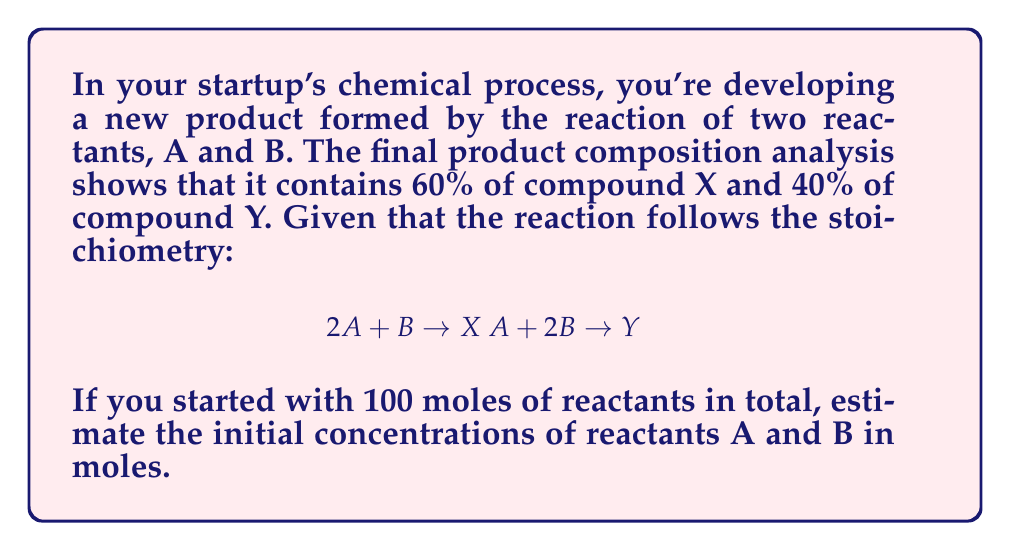Solve this math problem. Let's approach this step-by-step:

1) Let $a$ be the number of moles of A and $b$ be the number of moles of B. We know:

   $a + b = 100$ (total moles)

2) The product contains 60% X and 40% Y. Let's assume we have 100 moles of product for simplicity. Then:

   60 moles of X
   40 moles of Y

3) From the stoichiometry:
   For X: $2A + B \rightarrow X$
   For Y: $A + 2B \rightarrow Y$

4) To produce 60 moles of X:
   $120$ moles of A and $60$ moles of B were consumed

5) To produce 40 moles of Y:
   $40$ moles of A and $80$ moles of B were consumed

6) Total consumption:
   A: $120 + 40 = 160$ moles
   B: $60 + 80 = 140$ moles

7) The ratio of A:B consumption is 160:140, which simplifies to 8:7

8) We can set up an equation:
   $\frac{a}{8} = \frac{b}{7}$

9) Combining with the total moles equation:
   $a + b = 100$
   $7a = 8b$

10) Solve this system of equations:
    $a = \frac{800}{15} \approx 53.33$
    $b = \frac{700}{15} \approx 46.67$

Therefore, the initial concentrations were approximately 53.33 moles of A and 46.67 moles of B.
Answer: A: 53.33 moles, B: 46.67 moles 